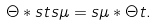<formula> <loc_0><loc_0><loc_500><loc_500>\Theta \ast s t s \mu = s \mu \ast \Theta t .</formula> 